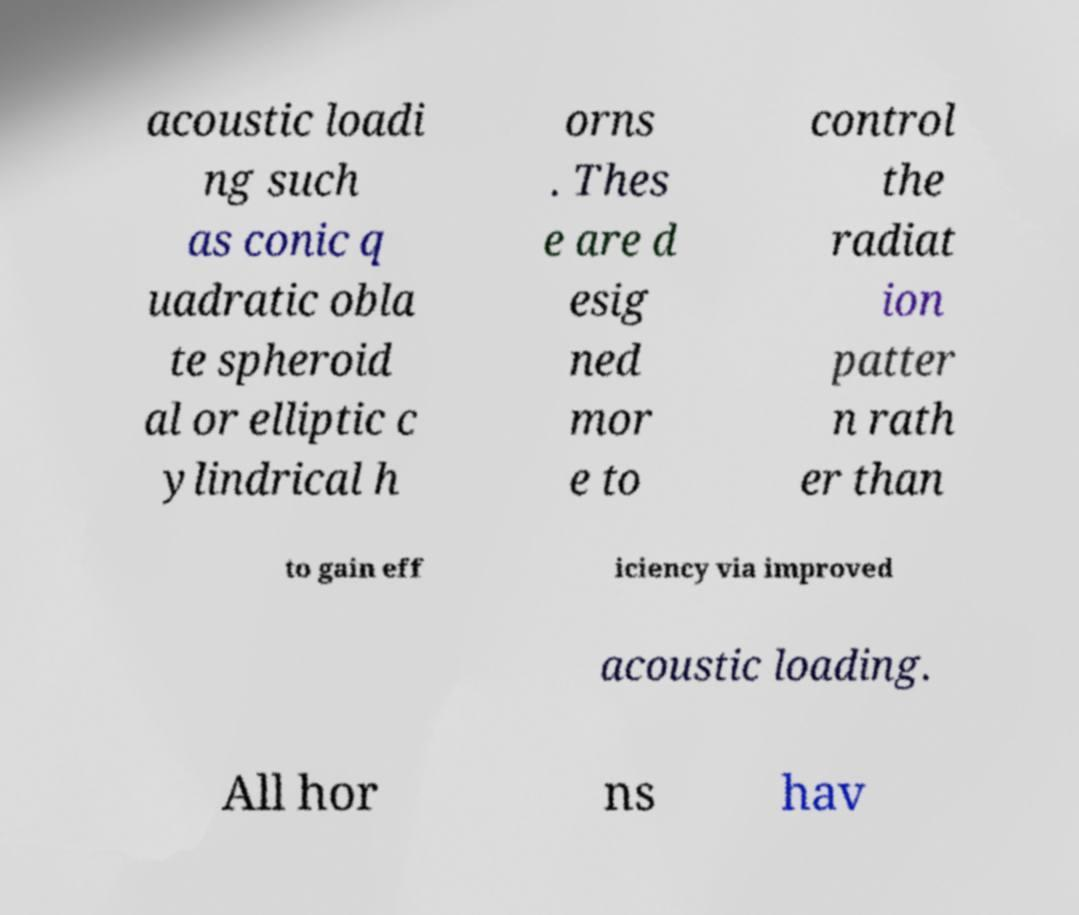Could you assist in decoding the text presented in this image and type it out clearly? acoustic loadi ng such as conic q uadratic obla te spheroid al or elliptic c ylindrical h orns . Thes e are d esig ned mor e to control the radiat ion patter n rath er than to gain eff iciency via improved acoustic loading. All hor ns hav 